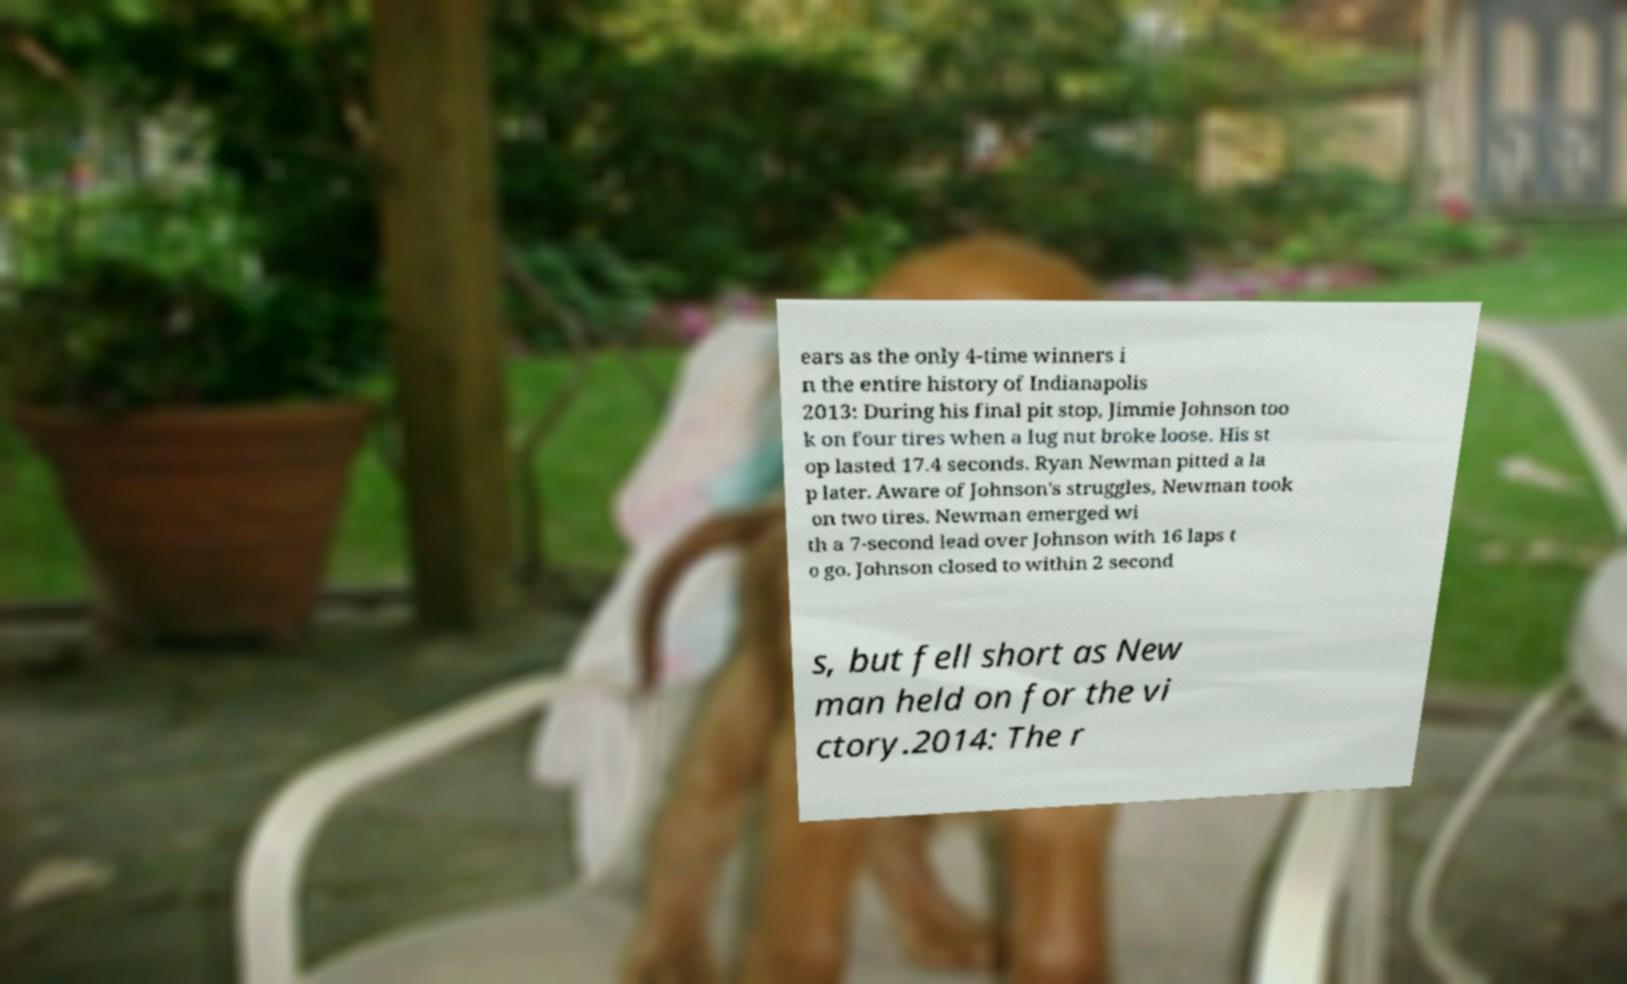Please identify and transcribe the text found in this image. ears as the only 4-time winners i n the entire history of Indianapolis 2013: During his final pit stop, Jimmie Johnson too k on four tires when a lug nut broke loose. His st op lasted 17.4 seconds. Ryan Newman pitted a la p later. Aware of Johnson's struggles, Newman took on two tires. Newman emerged wi th a 7-second lead over Johnson with 16 laps t o go. Johnson closed to within 2 second s, but fell short as New man held on for the vi ctory.2014: The r 